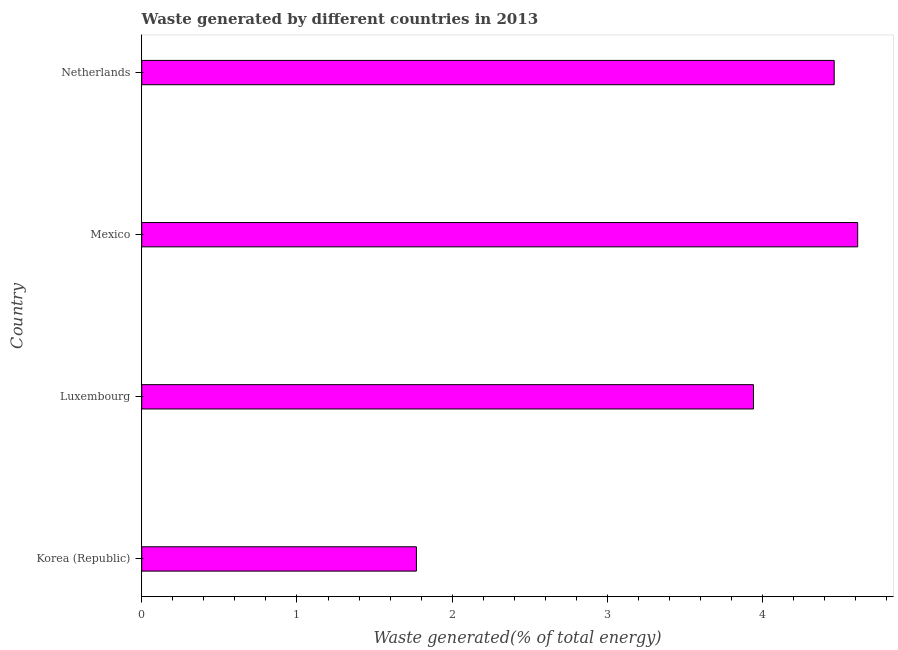Does the graph contain any zero values?
Keep it short and to the point. No. What is the title of the graph?
Make the answer very short. Waste generated by different countries in 2013. What is the label or title of the X-axis?
Your answer should be compact. Waste generated(% of total energy). What is the amount of waste generated in Korea (Republic)?
Your answer should be very brief. 1.77. Across all countries, what is the maximum amount of waste generated?
Keep it short and to the point. 4.61. Across all countries, what is the minimum amount of waste generated?
Give a very brief answer. 1.77. In which country was the amount of waste generated maximum?
Offer a very short reply. Mexico. In which country was the amount of waste generated minimum?
Give a very brief answer. Korea (Republic). What is the sum of the amount of waste generated?
Your answer should be compact. 14.78. What is the difference between the amount of waste generated in Luxembourg and Netherlands?
Provide a succinct answer. -0.52. What is the average amount of waste generated per country?
Provide a short and direct response. 3.69. What is the median amount of waste generated?
Provide a succinct answer. 4.2. In how many countries, is the amount of waste generated greater than 0.8 %?
Offer a very short reply. 4. What is the ratio of the amount of waste generated in Korea (Republic) to that in Netherlands?
Your answer should be very brief. 0.4. Is the amount of waste generated in Korea (Republic) less than that in Mexico?
Provide a short and direct response. Yes. What is the difference between the highest and the second highest amount of waste generated?
Provide a short and direct response. 0.15. What is the difference between the highest and the lowest amount of waste generated?
Give a very brief answer. 2.84. Are all the bars in the graph horizontal?
Make the answer very short. Yes. How many countries are there in the graph?
Provide a short and direct response. 4. What is the difference between two consecutive major ticks on the X-axis?
Offer a very short reply. 1. What is the Waste generated(% of total energy) in Korea (Republic)?
Ensure brevity in your answer.  1.77. What is the Waste generated(% of total energy) of Luxembourg?
Your response must be concise. 3.94. What is the Waste generated(% of total energy) in Mexico?
Offer a terse response. 4.61. What is the Waste generated(% of total energy) of Netherlands?
Keep it short and to the point. 4.46. What is the difference between the Waste generated(% of total energy) in Korea (Republic) and Luxembourg?
Keep it short and to the point. -2.17. What is the difference between the Waste generated(% of total energy) in Korea (Republic) and Mexico?
Your answer should be very brief. -2.84. What is the difference between the Waste generated(% of total energy) in Korea (Republic) and Netherlands?
Ensure brevity in your answer.  -2.69. What is the difference between the Waste generated(% of total energy) in Luxembourg and Mexico?
Offer a terse response. -0.67. What is the difference between the Waste generated(% of total energy) in Luxembourg and Netherlands?
Ensure brevity in your answer.  -0.52. What is the difference between the Waste generated(% of total energy) in Mexico and Netherlands?
Your answer should be very brief. 0.15. What is the ratio of the Waste generated(% of total energy) in Korea (Republic) to that in Luxembourg?
Offer a terse response. 0.45. What is the ratio of the Waste generated(% of total energy) in Korea (Republic) to that in Mexico?
Offer a very short reply. 0.38. What is the ratio of the Waste generated(% of total energy) in Korea (Republic) to that in Netherlands?
Keep it short and to the point. 0.4. What is the ratio of the Waste generated(% of total energy) in Luxembourg to that in Mexico?
Your answer should be very brief. 0.85. What is the ratio of the Waste generated(% of total energy) in Luxembourg to that in Netherlands?
Give a very brief answer. 0.88. What is the ratio of the Waste generated(% of total energy) in Mexico to that in Netherlands?
Make the answer very short. 1.03. 